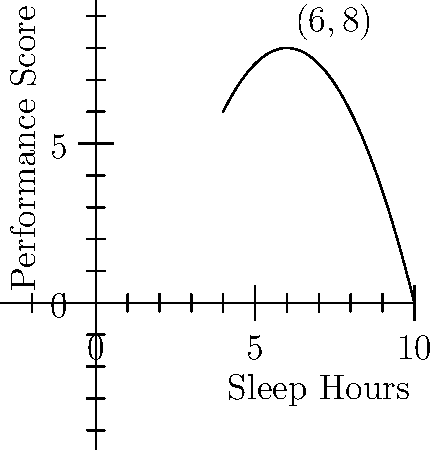As a star wide receiver, you've been tracking your sleep hours and on-field performance scores. The polynomial regression model $f(x) = -0.5x^2 + 6x - 10$ represents the relationship between sleep hours (x) and performance score (y). What is the optimal number of sleep hours for peak performance, and what is the corresponding performance score? To find the optimal number of sleep hours for peak performance, we need to find the vertex of the parabola. For a quadratic function in the form $f(x) = ax^2 + bx + c$, the x-coordinate of the vertex is given by $x = -\frac{b}{2a}$.

1) Identify $a$ and $b$ from the given function $f(x) = -0.5x^2 + 6x - 10$:
   $a = -0.5$ and $b = 6$

2) Calculate the optimal sleep hours:
   $x = -\frac{b}{2a} = -\frac{6}{2(-0.5)} = \frac{6}{1} = 6$ hours

3) To find the corresponding performance score, substitute $x = 6$ into the original function:
   $f(6) = -0.5(6)^2 + 6(6) - 10$
   $= -0.5(36) + 36 - 10$
   $= -18 + 36 - 10$
   $= 8$

Therefore, the optimal number of sleep hours is 6, and the corresponding peak performance score is 8.
Answer: 6 hours of sleep; performance score of 8 